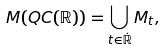<formula> <loc_0><loc_0><loc_500><loc_500>M ( Q C ( \mathbb { R } ) ) = \bigcup _ { t \in \dot { \mathbb { R } } } M _ { t } ,</formula> 